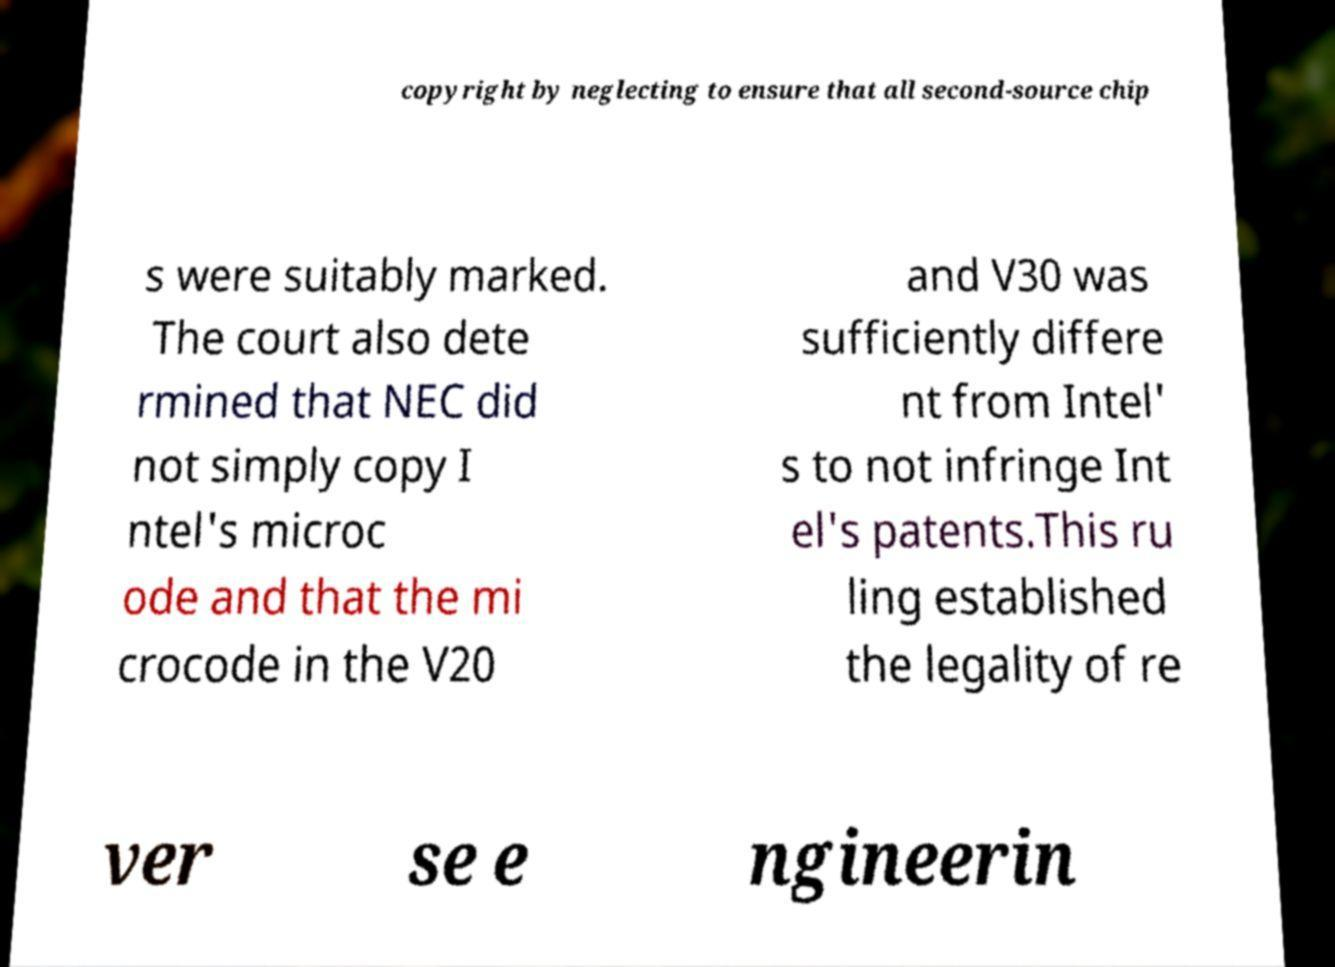There's text embedded in this image that I need extracted. Can you transcribe it verbatim? copyright by neglecting to ensure that all second-source chip s were suitably marked. The court also dete rmined that NEC did not simply copy I ntel's microc ode and that the mi crocode in the V20 and V30 was sufficiently differe nt from Intel' s to not infringe Int el's patents.This ru ling established the legality of re ver se e ngineerin 